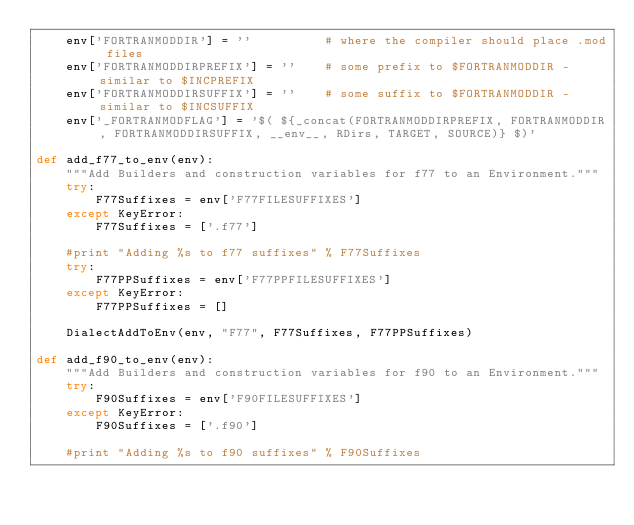Convert code to text. <code><loc_0><loc_0><loc_500><loc_500><_Python_>    env['FORTRANMODDIR'] = ''          # where the compiler should place .mod files
    env['FORTRANMODDIRPREFIX'] = ''    # some prefix to $FORTRANMODDIR - similar to $INCPREFIX
    env['FORTRANMODDIRSUFFIX'] = ''    # some suffix to $FORTRANMODDIR - similar to $INCSUFFIX
    env['_FORTRANMODFLAG'] = '$( ${_concat(FORTRANMODDIRPREFIX, FORTRANMODDIR, FORTRANMODDIRSUFFIX, __env__, RDirs, TARGET, SOURCE)} $)'

def add_f77_to_env(env):
    """Add Builders and construction variables for f77 to an Environment."""
    try:
        F77Suffixes = env['F77FILESUFFIXES']
    except KeyError:
        F77Suffixes = ['.f77']

    #print "Adding %s to f77 suffixes" % F77Suffixes
    try:
        F77PPSuffixes = env['F77PPFILESUFFIXES']
    except KeyError:
        F77PPSuffixes = []

    DialectAddToEnv(env, "F77", F77Suffixes, F77PPSuffixes)

def add_f90_to_env(env):
    """Add Builders and construction variables for f90 to an Environment."""
    try:
        F90Suffixes = env['F90FILESUFFIXES']
    except KeyError:
        F90Suffixes = ['.f90']

    #print "Adding %s to f90 suffixes" % F90Suffixes</code> 